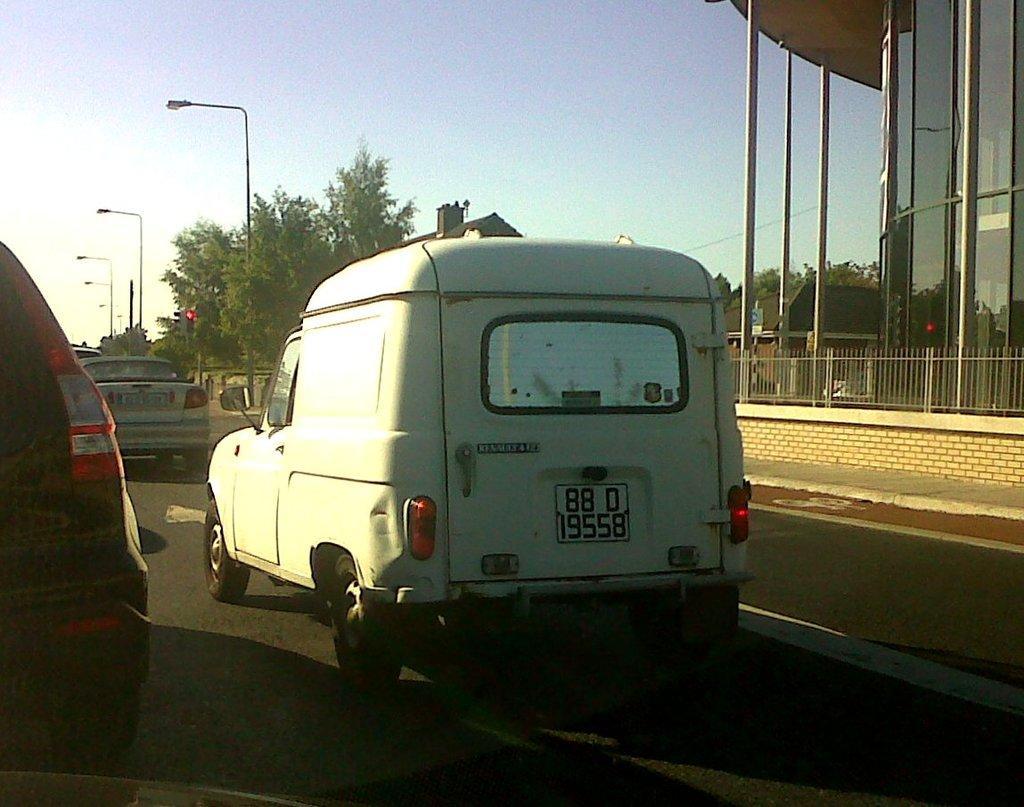Can you describe this image briefly? In this picture we can see some vehicles are moving on the road, side we can see some buildings, trees. 